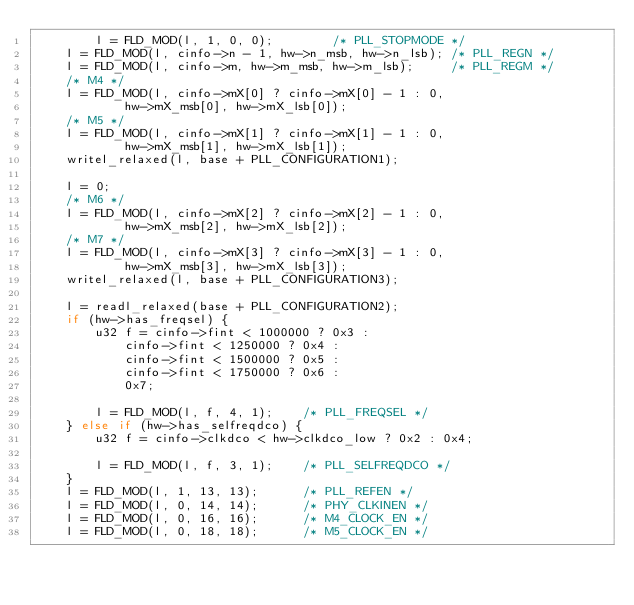<code> <loc_0><loc_0><loc_500><loc_500><_C_>		l = FLD_MOD(l, 1, 0, 0);		/* PLL_STOPMODE */
	l = FLD_MOD(l, cinfo->n - 1, hw->n_msb, hw->n_lsb);	/* PLL_REGN */
	l = FLD_MOD(l, cinfo->m, hw->m_msb, hw->m_lsb);		/* PLL_REGM */
	/* M4 */
	l = FLD_MOD(l, cinfo->mX[0] ? cinfo->mX[0] - 1 : 0,
			hw->mX_msb[0], hw->mX_lsb[0]);
	/* M5 */
	l = FLD_MOD(l, cinfo->mX[1] ? cinfo->mX[1] - 1 : 0,
			hw->mX_msb[1], hw->mX_lsb[1]);
	writel_relaxed(l, base + PLL_CONFIGURATION1);

	l = 0;
	/* M6 */
	l = FLD_MOD(l, cinfo->mX[2] ? cinfo->mX[2] - 1 : 0,
			hw->mX_msb[2], hw->mX_lsb[2]);
	/* M7 */
	l = FLD_MOD(l, cinfo->mX[3] ? cinfo->mX[3] - 1 : 0,
			hw->mX_msb[3], hw->mX_lsb[3]);
	writel_relaxed(l, base + PLL_CONFIGURATION3);

	l = readl_relaxed(base + PLL_CONFIGURATION2);
	if (hw->has_freqsel) {
		u32 f = cinfo->fint < 1000000 ? 0x3 :
			cinfo->fint < 1250000 ? 0x4 :
			cinfo->fint < 1500000 ? 0x5 :
			cinfo->fint < 1750000 ? 0x6 :
			0x7;

		l = FLD_MOD(l, f, 4, 1);	/* PLL_FREQSEL */
	} else if (hw->has_selfreqdco) {
		u32 f = cinfo->clkdco < hw->clkdco_low ? 0x2 : 0x4;

		l = FLD_MOD(l, f, 3, 1);	/* PLL_SELFREQDCO */
	}
	l = FLD_MOD(l, 1, 13, 13);		/* PLL_REFEN */
	l = FLD_MOD(l, 0, 14, 14);		/* PHY_CLKINEN */
	l = FLD_MOD(l, 0, 16, 16);		/* M4_CLOCK_EN */
	l = FLD_MOD(l, 0, 18, 18);		/* M5_CLOCK_EN */</code> 